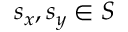Convert formula to latex. <formula><loc_0><loc_0><loc_500><loc_500>s _ { x } , s _ { y } \in S</formula> 